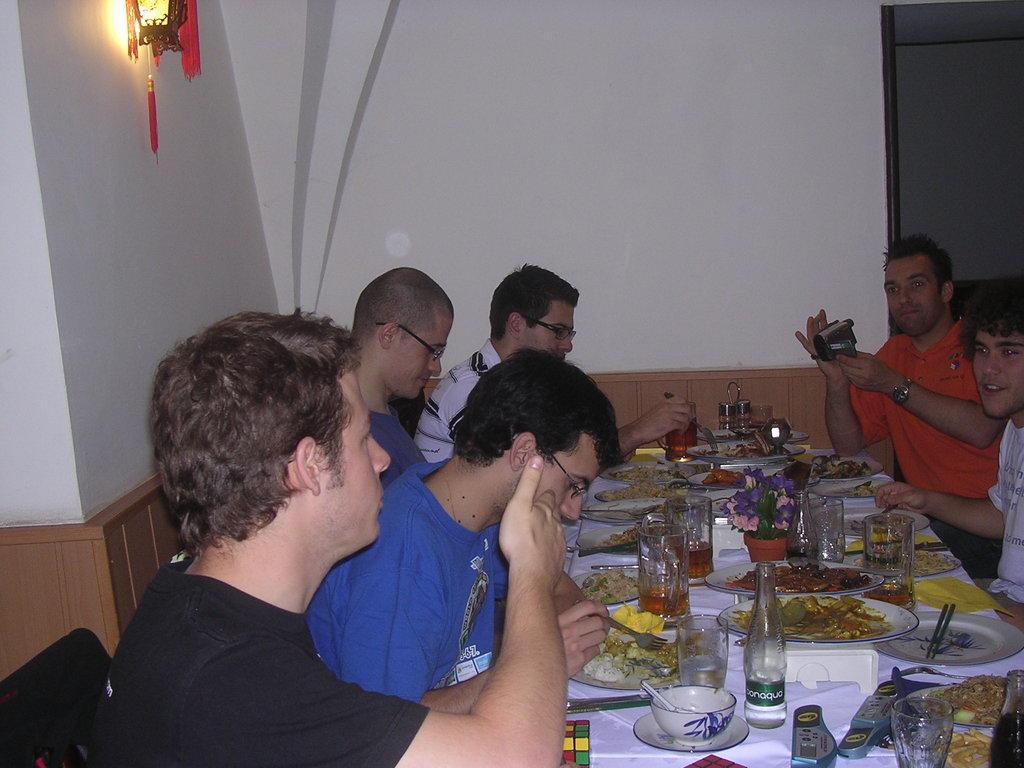Could you give a brief overview of what you see in this image? In this picture we can see a group of men sitting on chairs where one is holding camera in his hand and in front of them on table we have plate with food items, glasses with drinks in it, bottles, bowl, dice, stand and in the background we can see wall, light. 